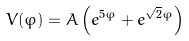<formula> <loc_0><loc_0><loc_500><loc_500>V ( \varphi ) = A \left ( e ^ { 5 \varphi } + e ^ { \sqrt { 2 } \varphi } \right )</formula> 